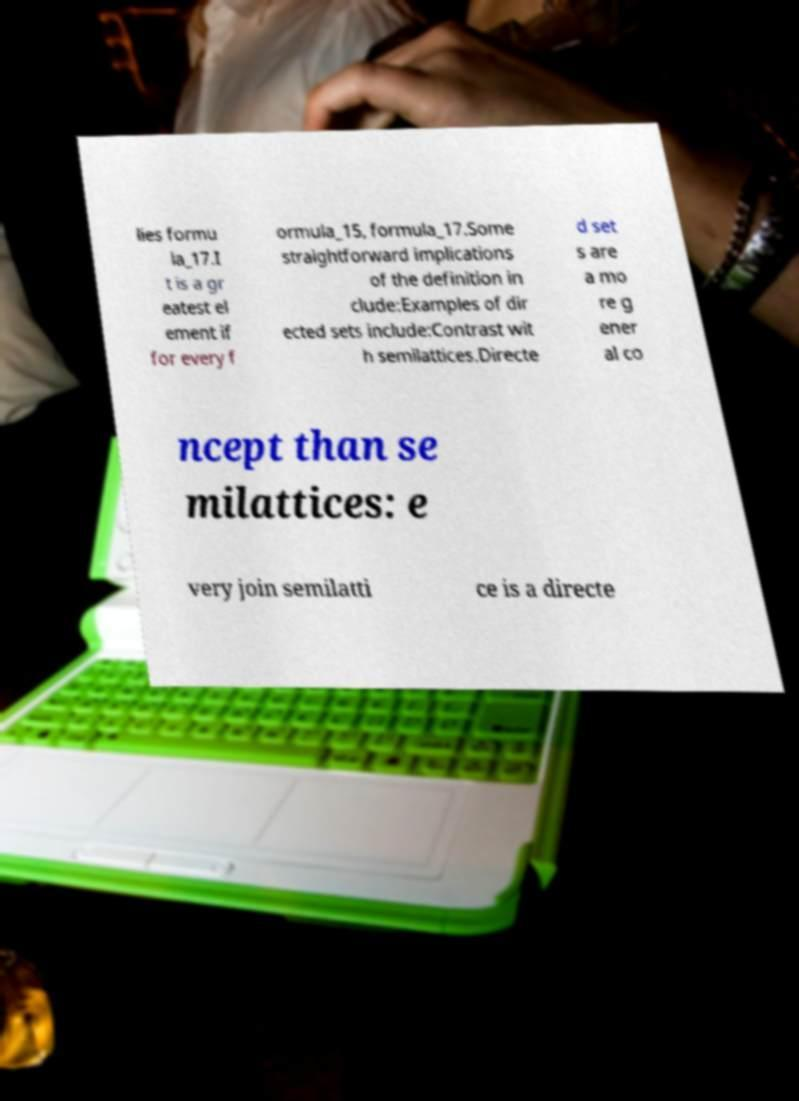There's text embedded in this image that I need extracted. Can you transcribe it verbatim? lies formu la_17.I t is a gr eatest el ement if for every f ormula_15, formula_17.Some straightforward implications of the definition in clude:Examples of dir ected sets include:Contrast wit h semilattices.Directe d set s are a mo re g ener al co ncept than se milattices: e very join semilatti ce is a directe 